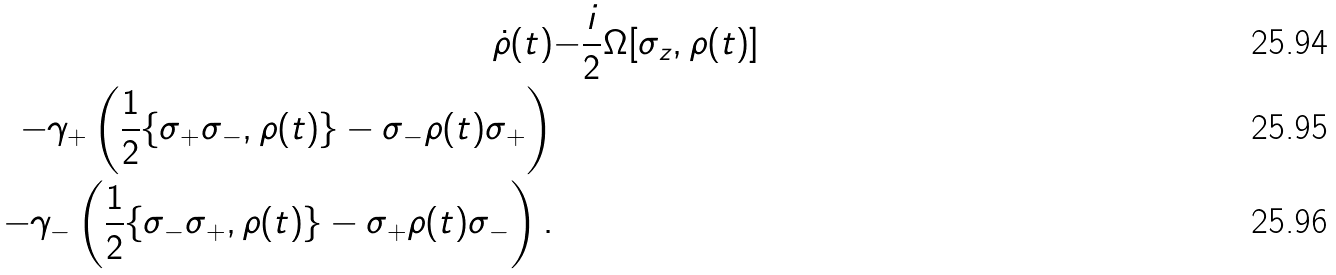<formula> <loc_0><loc_0><loc_500><loc_500>\dot { \rho } ( t ) & { - \frac { i } { 2 } } \Omega [ \sigma _ { z } , \rho ( t ) ] \\ - \gamma _ { + } \left ( \frac { 1 } { 2 } \{ \sigma _ { + } \sigma _ { - } , \rho ( t ) \} - \sigma _ { - } \rho ( t ) \sigma _ { + } \right ) \\ - \gamma _ { - } \left ( \frac { 1 } { 2 } \{ \sigma _ { - } \sigma _ { + } , \rho ( t ) \} - \sigma _ { + } \rho ( t ) \sigma _ { - } \right ) .</formula> 